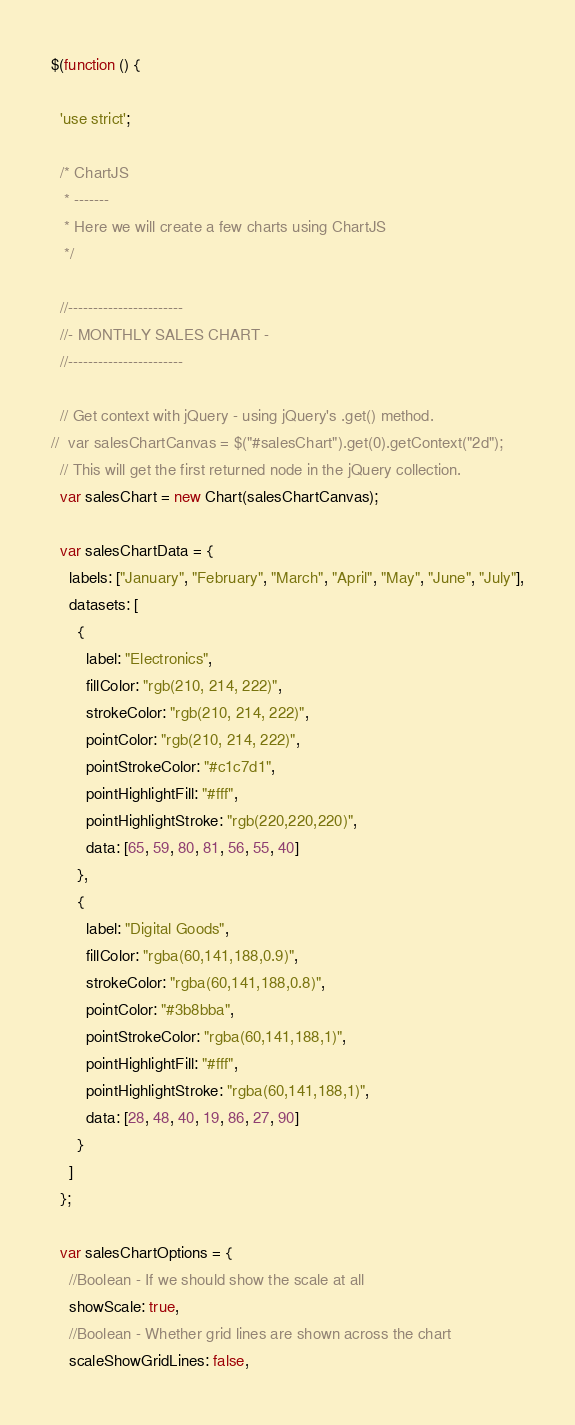Convert code to text. <code><loc_0><loc_0><loc_500><loc_500><_JavaScript_>$(function () {

  'use strict';

  /* ChartJS
   * -------
   * Here we will create a few charts using ChartJS
   */

  //-----------------------
  //- MONTHLY SALES CHART -
  //-----------------------

  // Get context with jQuery - using jQuery's .get() method.
//  var salesChartCanvas = $("#salesChart").get(0).getContext("2d");
  // This will get the first returned node in the jQuery collection.
  var salesChart = new Chart(salesChartCanvas);

  var salesChartData = {
    labels: ["January", "February", "March", "April", "May", "June", "July"],
    datasets: [
      {
        label: "Electronics",
        fillColor: "rgb(210, 214, 222)",
        strokeColor: "rgb(210, 214, 222)",
        pointColor: "rgb(210, 214, 222)",
        pointStrokeColor: "#c1c7d1",
        pointHighlightFill: "#fff",
        pointHighlightStroke: "rgb(220,220,220)",
        data: [65, 59, 80, 81, 56, 55, 40]
      },
      {
        label: "Digital Goods",
        fillColor: "rgba(60,141,188,0.9)",
        strokeColor: "rgba(60,141,188,0.8)",
        pointColor: "#3b8bba",
        pointStrokeColor: "rgba(60,141,188,1)",
        pointHighlightFill: "#fff",
        pointHighlightStroke: "rgba(60,141,188,1)",
        data: [28, 48, 40, 19, 86, 27, 90]
      }
    ]
  };

  var salesChartOptions = {
    //Boolean - If we should show the scale at all
    showScale: true,
    //Boolean - Whether grid lines are shown across the chart
    scaleShowGridLines: false,</code> 